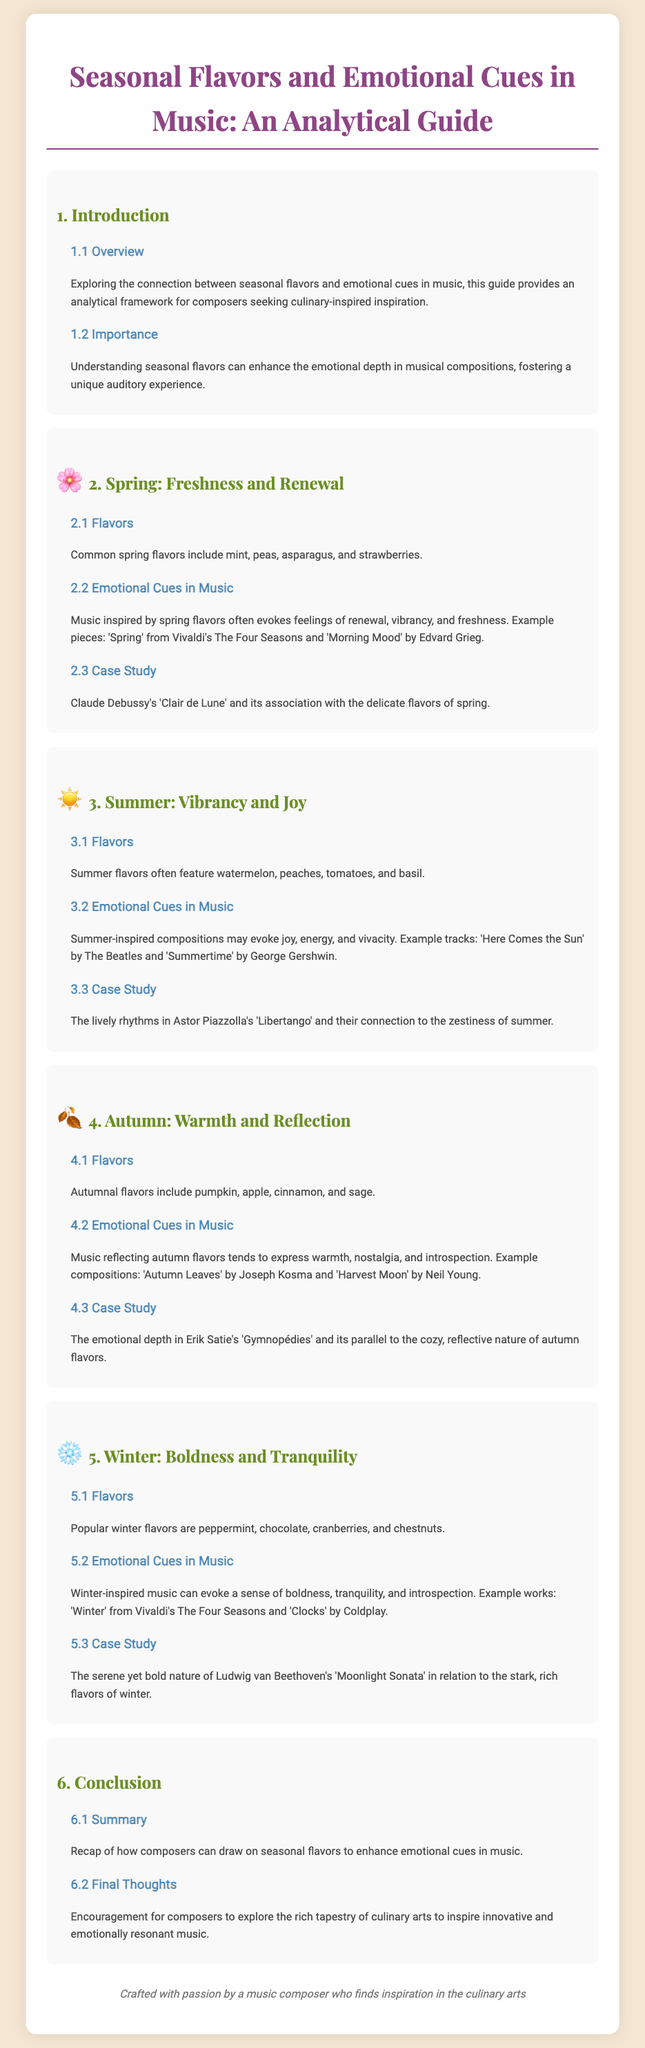what is the title of the document? The title is provided at the top of the document and summarizes the overall theme, which is the connection between seasonal flavors and emotional cues in music.
Answer: Seasonal Flavors and Emotional Cues in Music: An Analytical Guide what season is associated with freshness and renewal? The section heading discusses spring as the season relating to these specific emotional and flavor cues.
Answer: Spring which fruit is commonly associated with summer flavors? The document lists various flavors associated with summer, specifically mentioning peaches as a common fruit.
Answer: Peaches name one piece of music that evokes autumn emotions. The document provides examples of musical pieces that capture the essence of autumn, naming 'Autumn Leaves' specifically.
Answer: Autumn Leaves how many case studies are included in total? By counting the case studies presented for each season, you can determine that there are four seasons covered, thus indicating four case studies in total.
Answer: 4 what flavor is linked with winter? The document lists several flavors for winter, explicitly mentioning peppermint as a prominent flavor linked to this season.
Answer: Peppermint what emotional cue is associated with summer-inspired compositions? The document states that summer-inspired music typically evokes feelings of joy, energy, and vivacity, which can be considered the emotional cues described.
Answer: Joy which composer wrote 'Clair de Lune'? The document attributes the piece 'Clair de Lune' to the composer Claude Debussy, as mentioned in the spring case study.
Answer: Claude Debussy what is the overarching theme of the conclusion section? The conclusion section provides a recap on how composers can utilize seasonal flavors to enhance emotional depth in their music, illustrating the document's main theme.
Answer: Recap of how composers can draw on seasonal flavors 